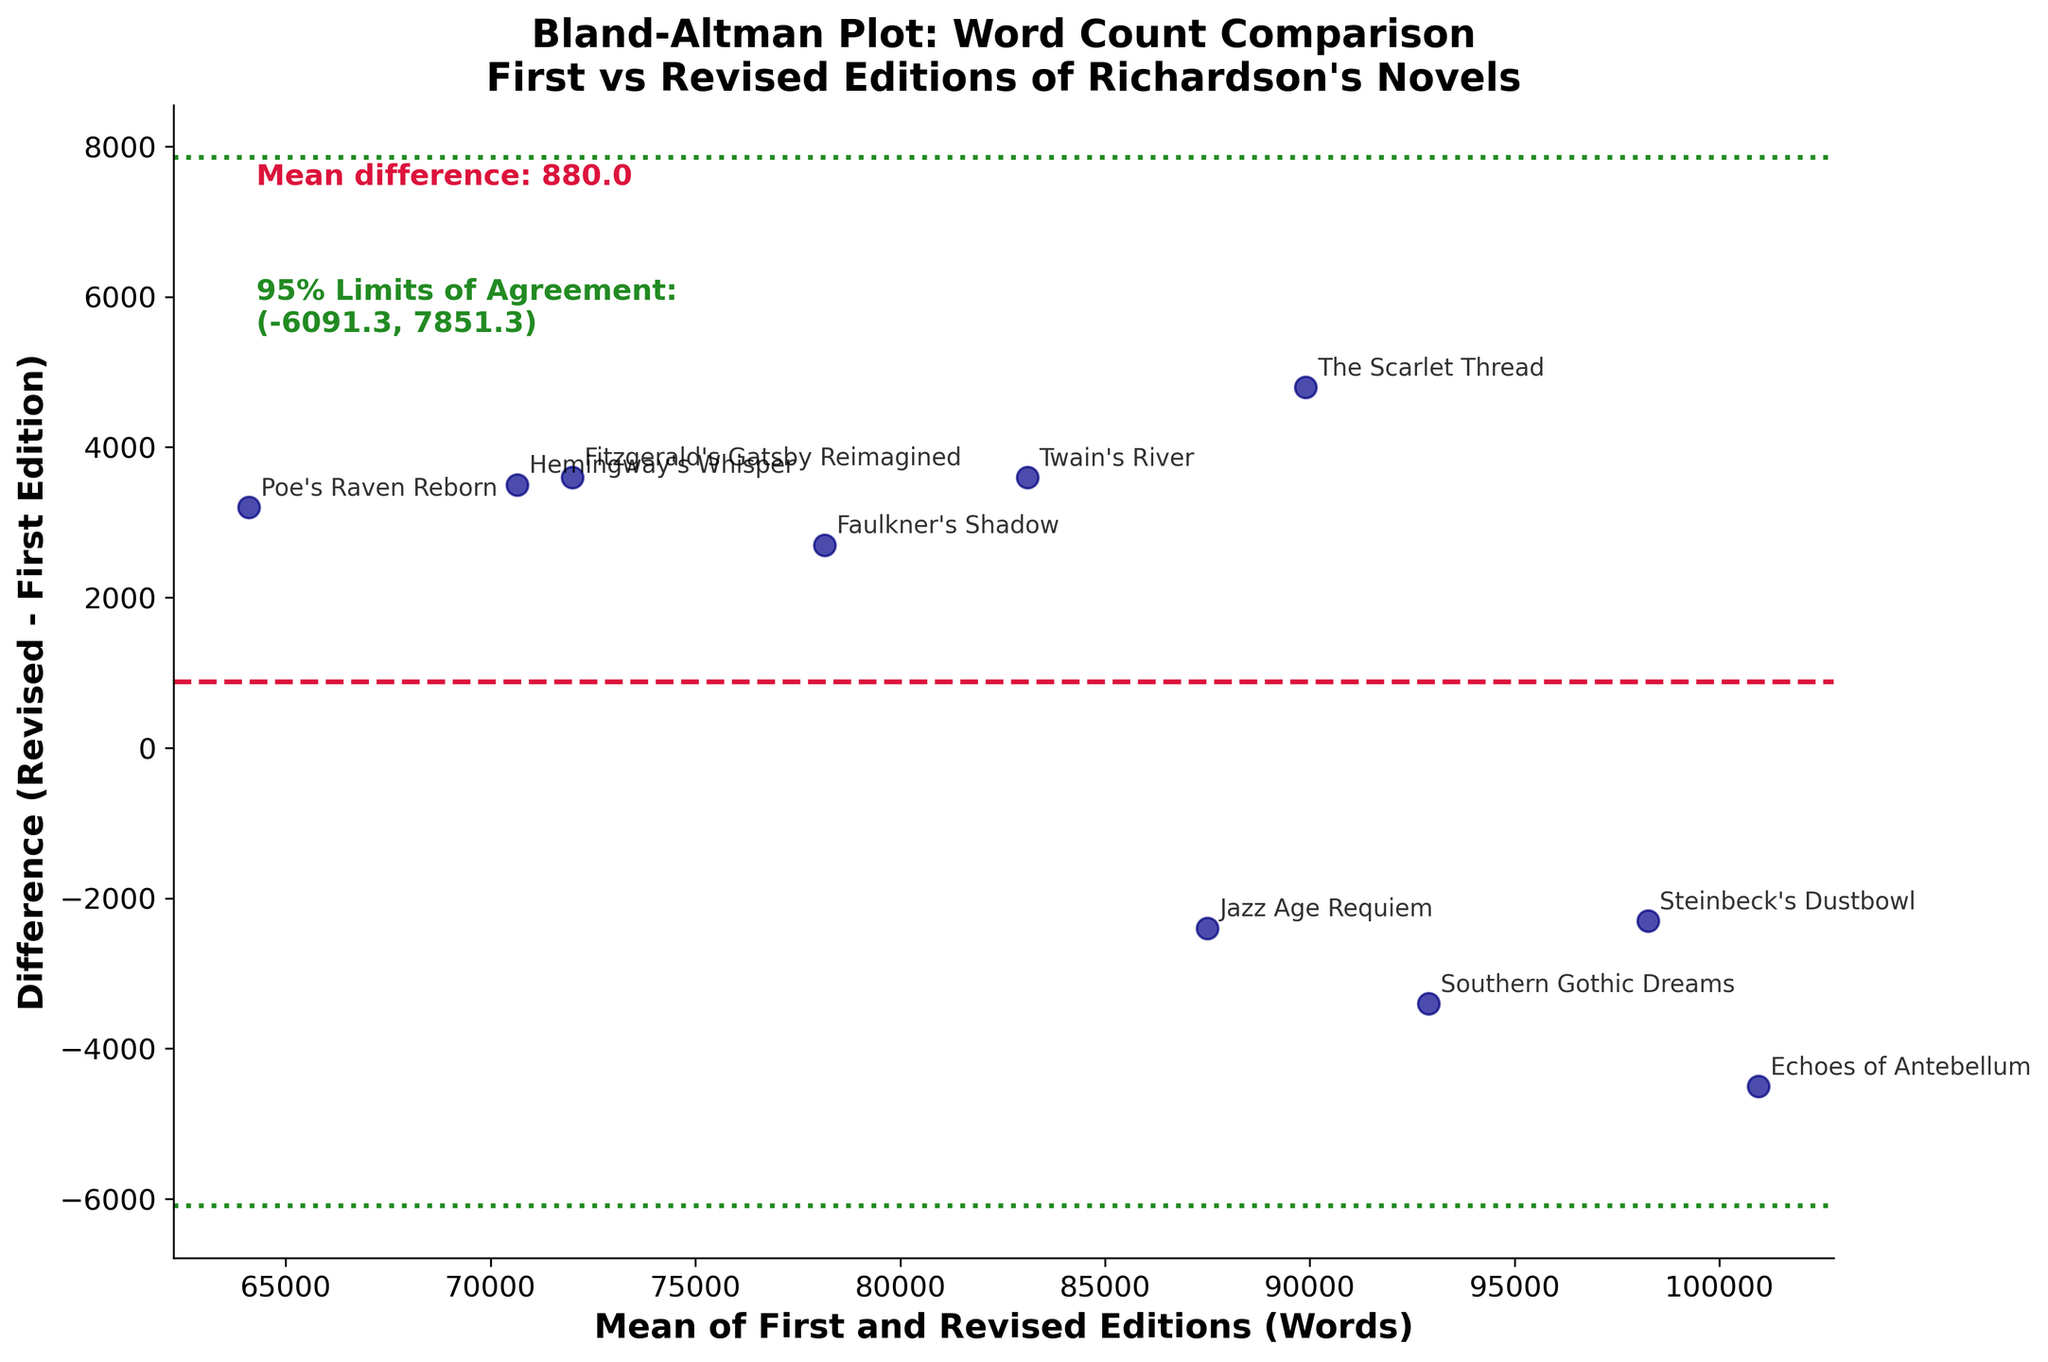Why does the title mention "First vs. Revised Editions of Richardson's Novels"? The title gives context about the data being plotted. It tells us that the Bland-Altman plot is comparing the word counts between the first and revised editions of Joe Martin Richardson’s novels. This information helps the viewer immediately understand what the data points represent.
Answer: It indicates the comparison of word counts between first and revised editions of the novels How many novels are being analyzed in the plot? To find this, we count the number of distinct data points (scattered circles) plotted on the Bland-Altman plot. Each point represents a novel.
Answer: 10 What do the green dashed lines represent? The green dashed lines indicate the 95% limits of agreement between the first and revised editions' word counts. These lines are typically set at mean difference ± 1.96 times the standard deviation of the differences.
Answer: 95% limits of agreement Which novel shows the smallest difference between the first and revised editions? Locate the data point closest to the value zero on the y-axis (difference). The novel with its annotation closest to y=0 represents the smallest difference.
Answer: Jazz Age Requiem What is the mean difference between the first and revised edition word counts? The mean difference is indicated by the horizontal red dashed line. Additionally, it should be annotated in the plot.
Answer: ~185 Determine the coordinates of the data point representing "The Scarlet Thread." Find the label "The Scarlet Thread" on the plot, and identify its corresponding (mean, difference) coordinates. The x-axis gives the mean word count, and the y-axis gives the difference.
Answer: (~89,400, ~4,800) Which novels lie beyond the 95% limits of agreement? Identify data points that lie outside the green dashed lines in the plot. These points represent novels where the difference between editions is greater than the 95% limits of agreement.
Answer: None Is the difference between word counts generally positive or negative? Examine the location of most data points in relation to the red dashed line (mean difference). If most points are above the line, the differences are generally positive; if below, they are negative.
Answer: Generally positive Can we conclude that the first editions usually have fewer words than the revised editions? Since the mean difference is positive and most data points are above zero, it suggests that the revised editions tend to have higher word counts compared to the first editions.
Answer: Yes Explain why "Southern Gothic Dreams" has a negative difference. A negative difference means the word count of the revised edition is less than that of the first edition. Look at where the data point for "Southern Gothic Dreams" lies below the zero line.
Answer: Revised edition has fewer words 